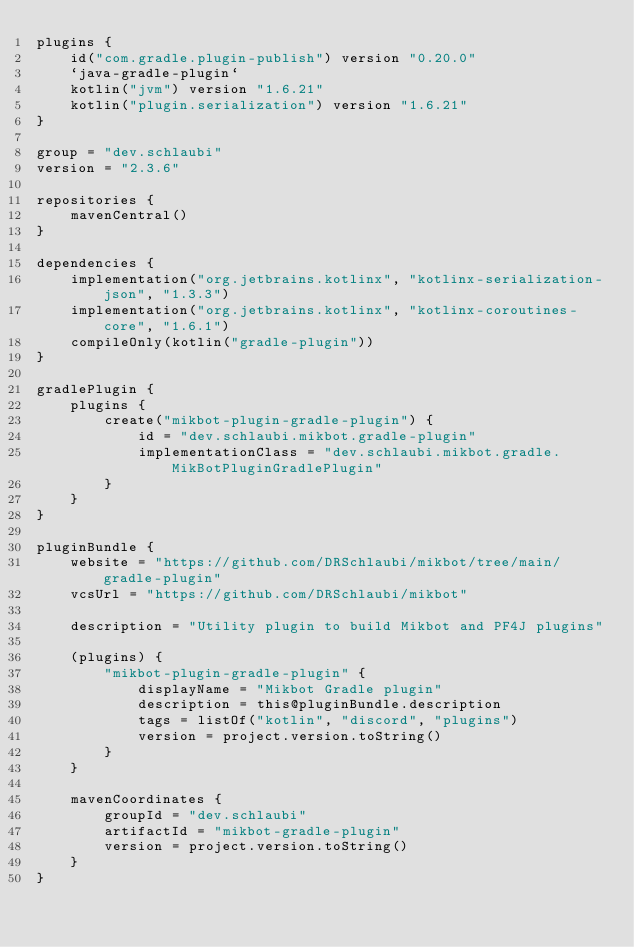Convert code to text. <code><loc_0><loc_0><loc_500><loc_500><_Kotlin_>plugins {
    id("com.gradle.plugin-publish") version "0.20.0"
    `java-gradle-plugin`
    kotlin("jvm") version "1.6.21"
    kotlin("plugin.serialization") version "1.6.21"
}

group = "dev.schlaubi"
version = "2.3.6"

repositories {
    mavenCentral()
}

dependencies {
    implementation("org.jetbrains.kotlinx", "kotlinx-serialization-json", "1.3.3")
    implementation("org.jetbrains.kotlinx", "kotlinx-coroutines-core", "1.6.1")
    compileOnly(kotlin("gradle-plugin"))
}

gradlePlugin {
    plugins {
        create("mikbot-plugin-gradle-plugin") {
            id = "dev.schlaubi.mikbot.gradle-plugin"
            implementationClass = "dev.schlaubi.mikbot.gradle.MikBotPluginGradlePlugin"
        }
    }
}

pluginBundle {
    website = "https://github.com/DRSchlaubi/mikbot/tree/main/gradle-plugin"
    vcsUrl = "https://github.com/DRSchlaubi/mikbot"

    description = "Utility plugin to build Mikbot and PF4J plugins"

    (plugins) {
        "mikbot-plugin-gradle-plugin" {
            displayName = "Mikbot Gradle plugin"
            description = this@pluginBundle.description
            tags = listOf("kotlin", "discord", "plugins")
            version = project.version.toString()
        }
    }

    mavenCoordinates {
        groupId = "dev.schlaubi"
        artifactId = "mikbot-gradle-plugin"
        version = project.version.toString()
    }
}
</code> 